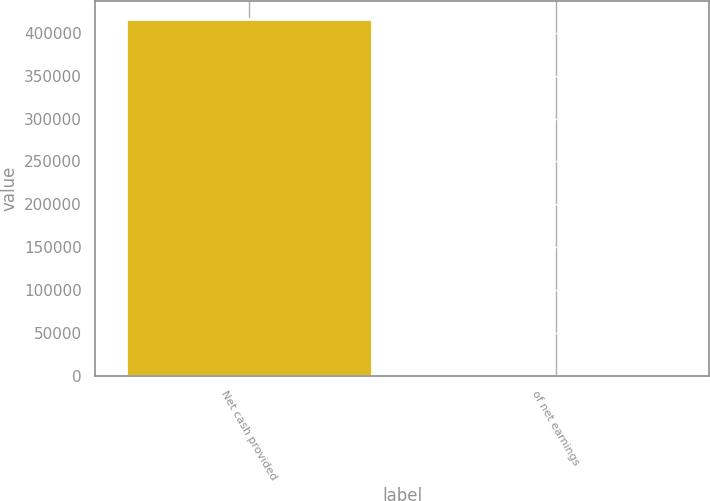Convert chart. <chart><loc_0><loc_0><loc_500><loc_500><bar_chart><fcel>Net cash provided<fcel>of net earnings<nl><fcel>416120<fcel>92.8<nl></chart> 